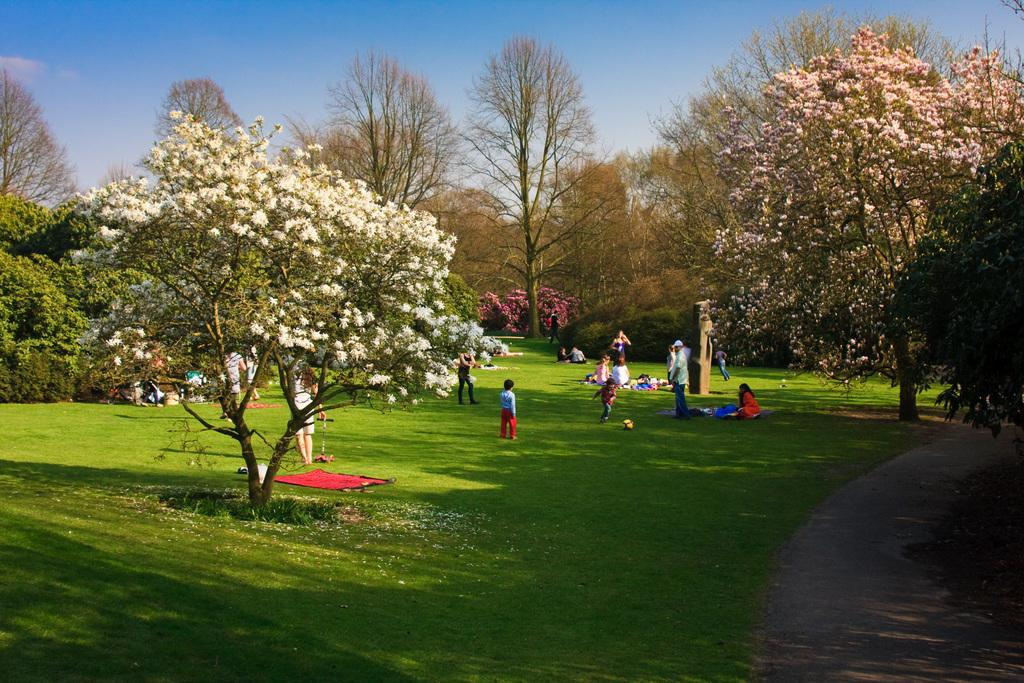Who or what is present in the image? There are people in the image. What else can be seen in the image besides the people? There are clothes and objects on the grass visible in the image. What type of surface can be seen in the image? There is a path in the image. What type of natural elements are present in the image? There are trees in the image. What is visible in the background of the image? The sky is visible in the background of the image. What type of pen is being used to draw on the clothes in the image? There is no pen or drawing activity present in the image; people are simply standing or sitting near clothes and objects on the grass. 